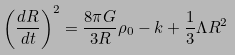<formula> <loc_0><loc_0><loc_500><loc_500>\left ( \frac { d R } { d t } \right ) ^ { 2 } = \frac { 8 \pi G } { 3 R } \rho _ { 0 } - k + \frac { 1 } { 3 } \Lambda R ^ { 2 }</formula> 